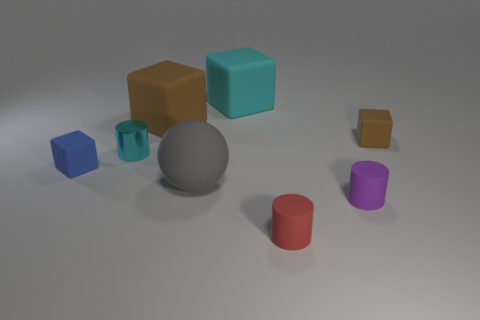Add 1 purple matte cylinders. How many objects exist? 9 Subtract all large cyan blocks. How many blocks are left? 3 Subtract all brown cubes. How many cubes are left? 2 Subtract 2 cylinders. How many cylinders are left? 1 Add 3 small red rubber things. How many small red rubber things are left? 4 Add 4 small cyan objects. How many small cyan objects exist? 5 Subtract 0 red blocks. How many objects are left? 8 Subtract all cylinders. How many objects are left? 5 Subtract all yellow spheres. Subtract all purple cylinders. How many spheres are left? 1 Subtract all red cubes. How many purple spheres are left? 0 